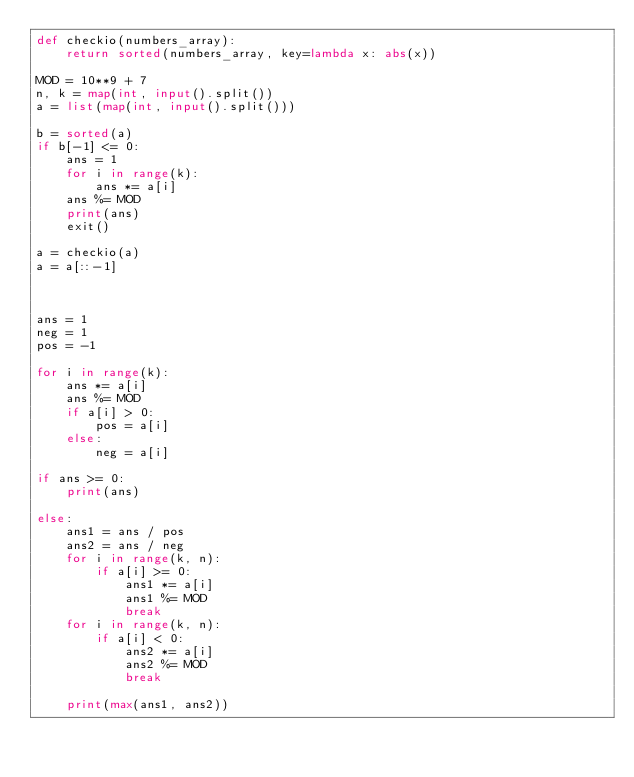<code> <loc_0><loc_0><loc_500><loc_500><_Python_>def checkio(numbers_array):
    return sorted(numbers_array, key=lambda x: abs(x))

MOD = 10**9 + 7
n, k = map(int, input().split())
a = list(map(int, input().split()))

b = sorted(a)
if b[-1] <= 0:
    ans = 1
    for i in range(k):
        ans *= a[i]
    ans %= MOD
    print(ans)
    exit()

a = checkio(a)
a = a[::-1]



ans = 1
neg = 1
pos = -1

for i in range(k):
    ans *= a[i]
    ans %= MOD
    if a[i] > 0:
        pos = a[i]
    else:
        neg = a[i]

if ans >= 0:
    print(ans)

else:
    ans1 = ans / pos
    ans2 = ans / neg
    for i in range(k, n):
        if a[i] >= 0:
            ans1 *= a[i]
            ans1 %= MOD
            break
    for i in range(k, n):
        if a[i] < 0:
            ans2 *= a[i]
            ans2 %= MOD
            break

    print(max(ans1, ans2))</code> 